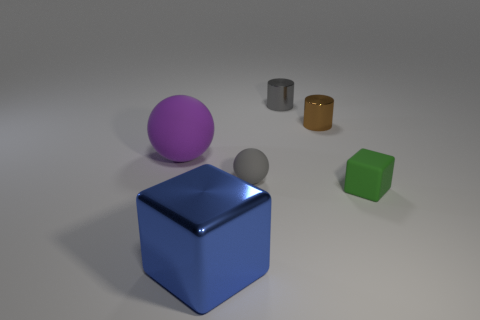Add 3 big purple rubber spheres. How many objects exist? 9 Subtract all matte blocks. Subtract all big blue metallic objects. How many objects are left? 4 Add 5 shiny objects. How many shiny objects are left? 8 Add 5 large shiny blocks. How many large shiny blocks exist? 6 Subtract 0 brown cubes. How many objects are left? 6 Subtract all balls. How many objects are left? 4 